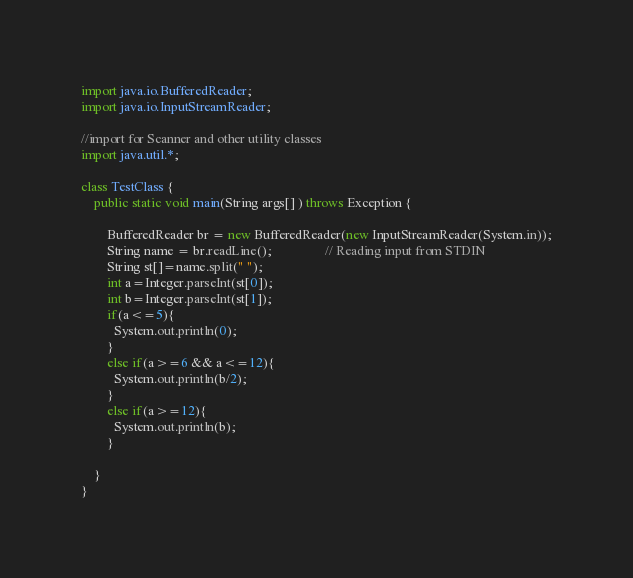<code> <loc_0><loc_0><loc_500><loc_500><_Java_>import java.io.BufferedReader;
import java.io.InputStreamReader;
 
//import for Scanner and other utility classes
import java.util.*;
 
class TestClass {
    public static void main(String args[] ) throws Exception {
       
        BufferedReader br = new BufferedReader(new InputStreamReader(System.in));
        String name = br.readLine();                // Reading input from STDIN
       	String st[]=name.split(" ");
      	int a=Integer.parseInt(st[0]);
      	int b=Integer.parseInt(st[1]);
      	if(a<=5){
          System.out.println(0);
        }
      	else if(a>=6 && a<=12){
          System.out.println(b/2);
        }
      	else if(a>=12){
          System.out.println(b);
        }
 
    }
}</code> 